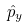<formula> <loc_0><loc_0><loc_500><loc_500>\hat { p } _ { y }</formula> 